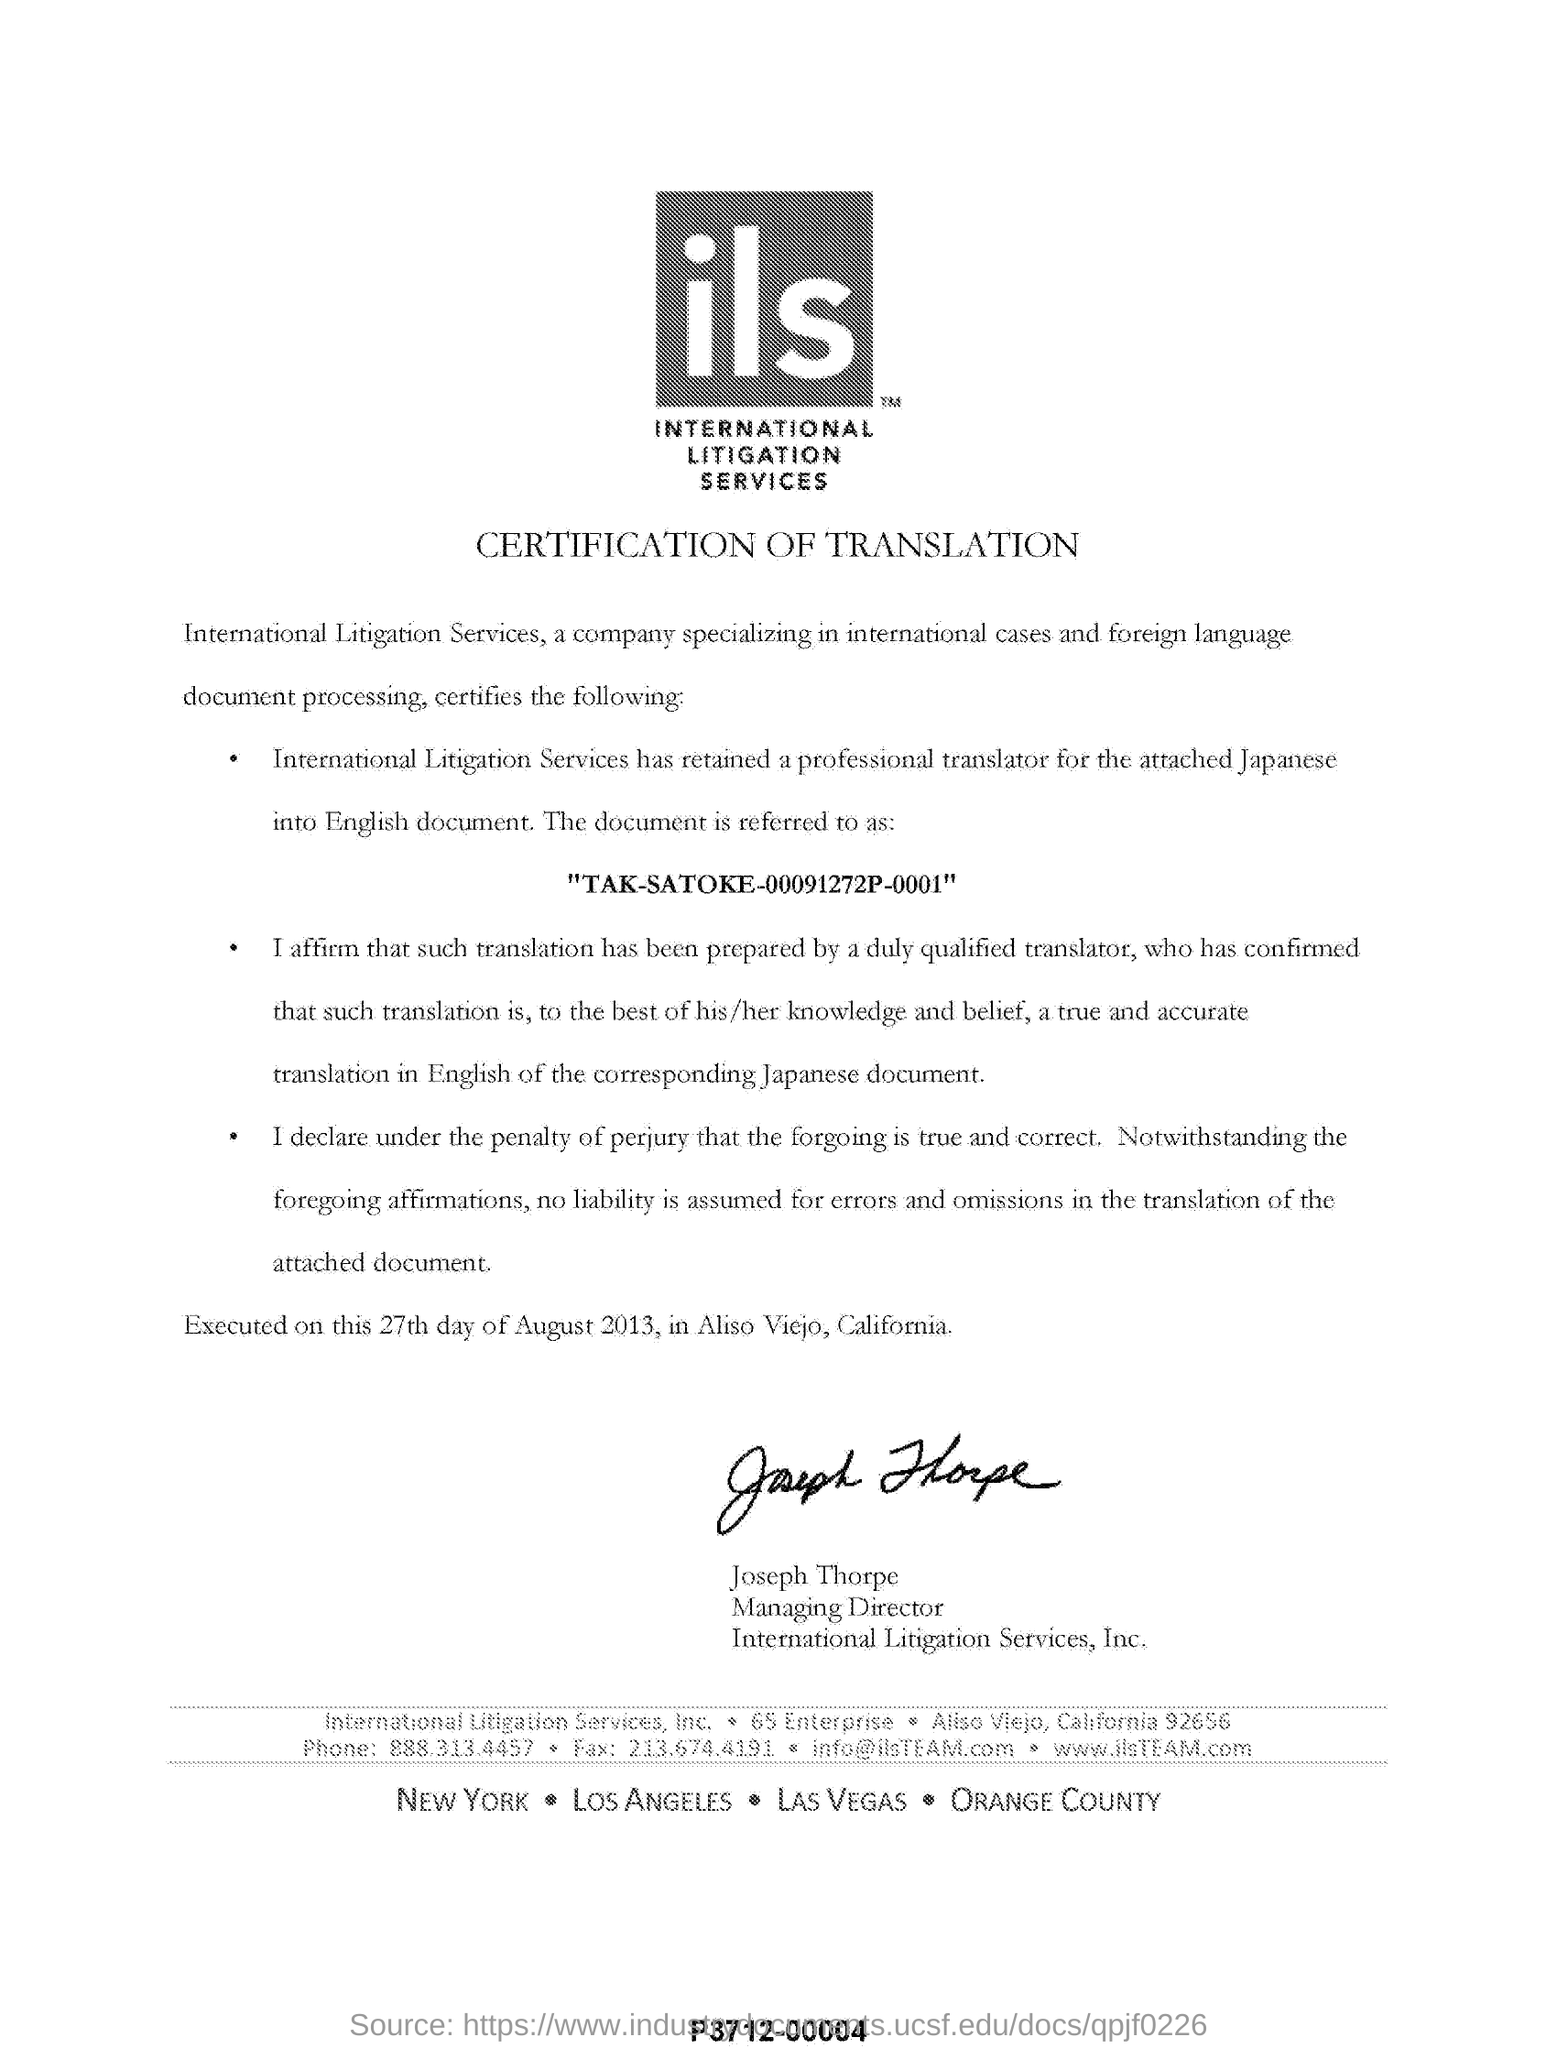Identify some key points in this picture. This will be executed on August 27th, 2013. This is a declaration that the speaker is certifying the translation. Joseph Thorpe is the managing director of International Litigation Services. Our specialization in international litigation services includes the handling of international cases and the processing of foreign language documents. 